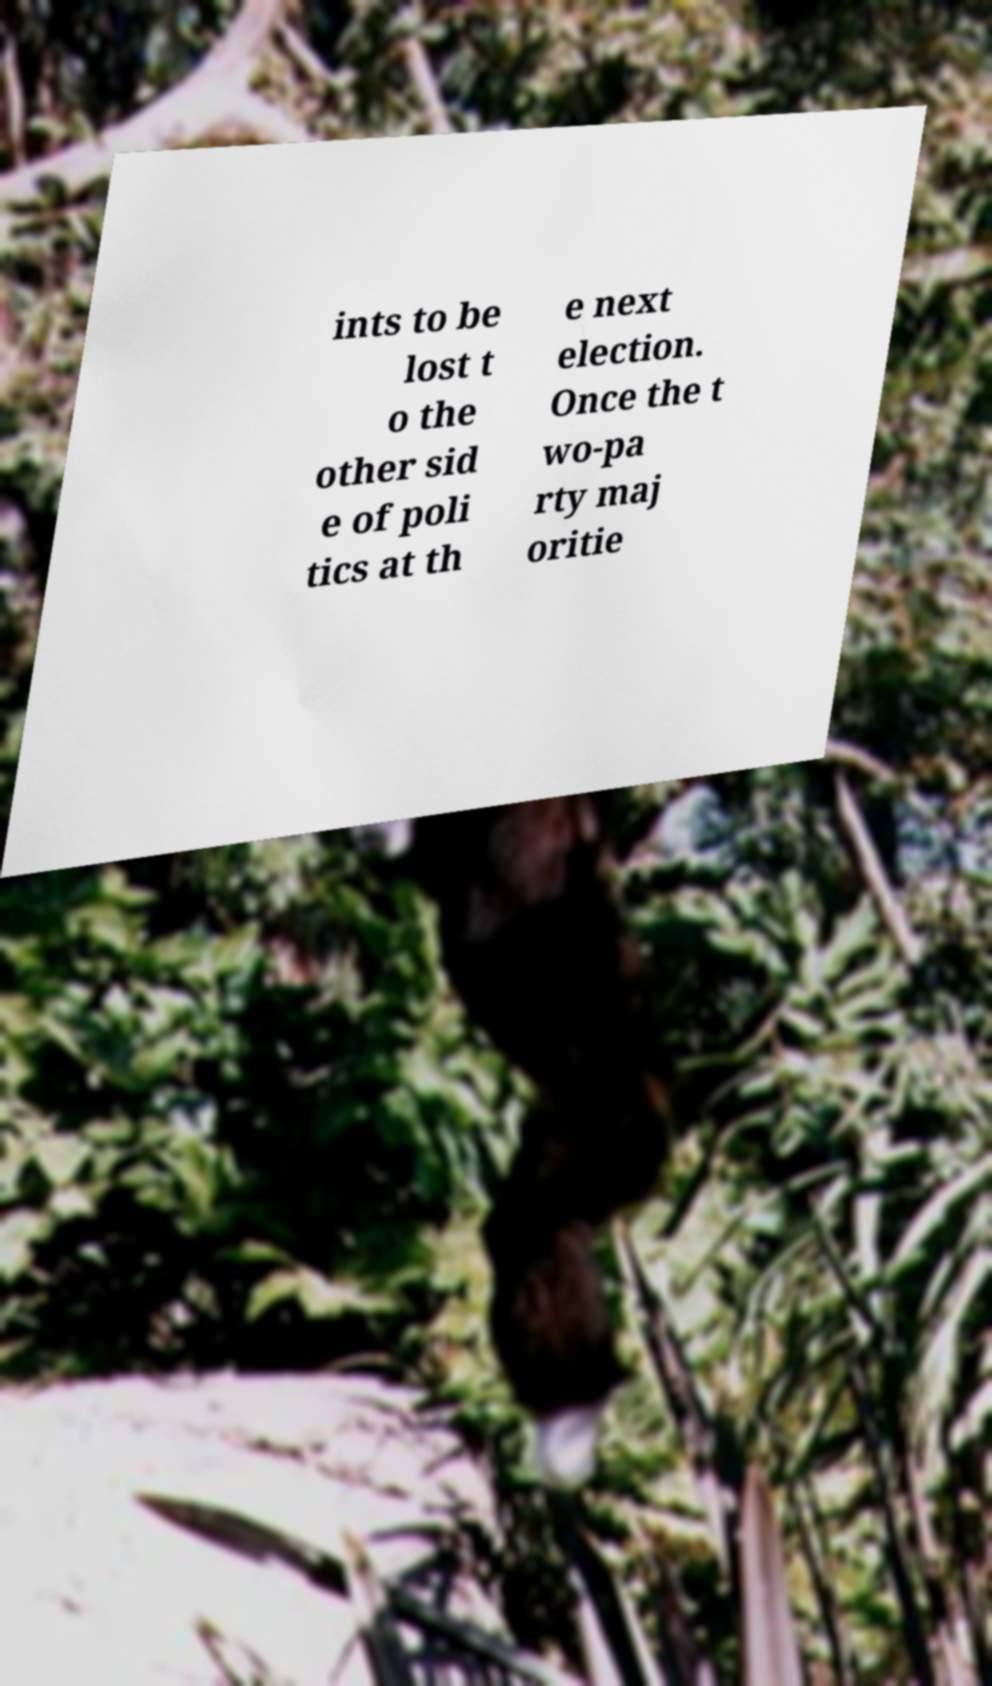Could you assist in decoding the text presented in this image and type it out clearly? ints to be lost t o the other sid e of poli tics at th e next election. Once the t wo-pa rty maj oritie 